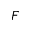<formula> <loc_0><loc_0><loc_500><loc_500>F</formula> 